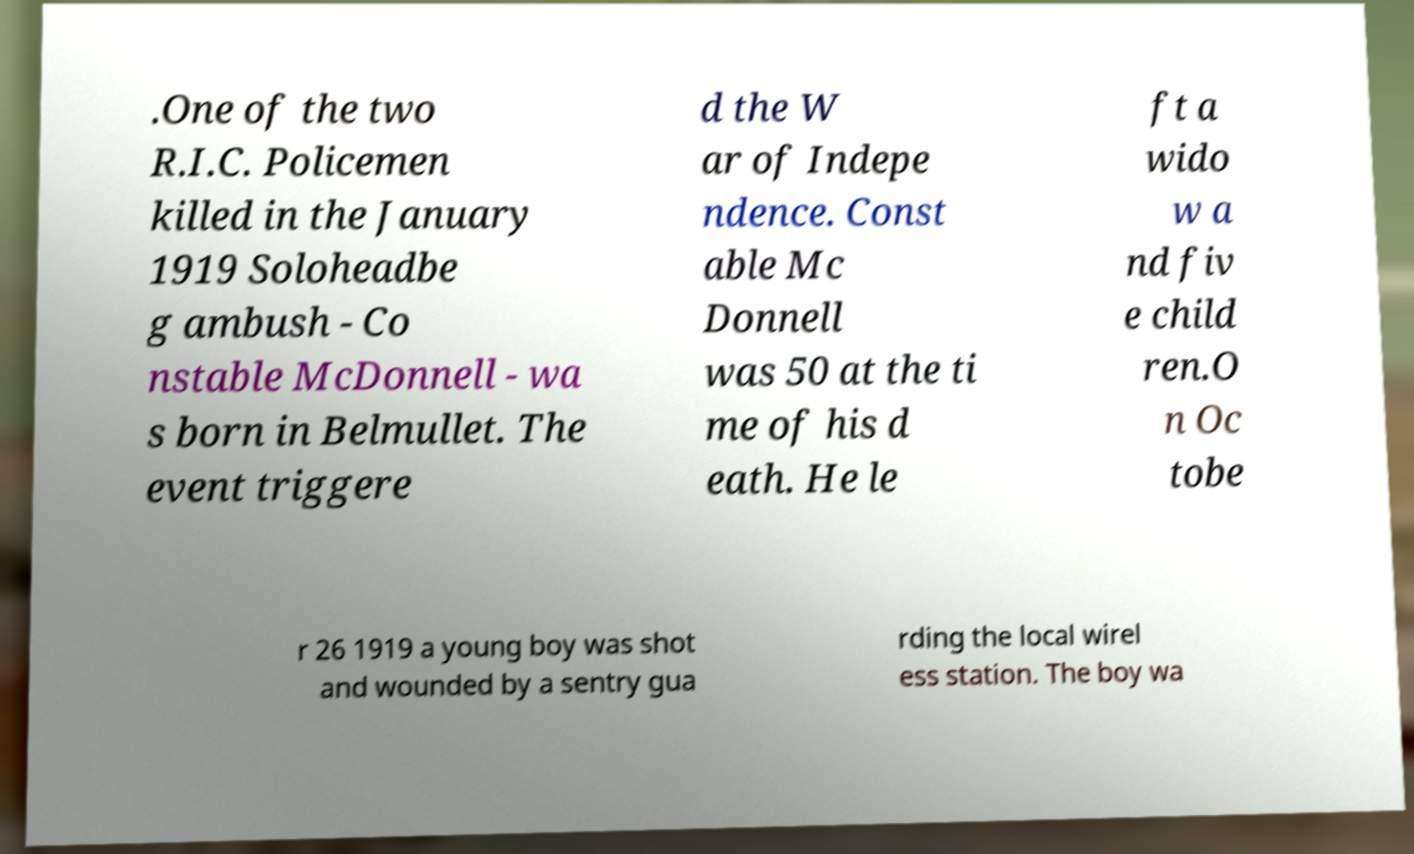Please read and relay the text visible in this image. What does it say? .One of the two R.I.C. Policemen killed in the January 1919 Soloheadbe g ambush - Co nstable McDonnell - wa s born in Belmullet. The event triggere d the W ar of Indepe ndence. Const able Mc Donnell was 50 at the ti me of his d eath. He le ft a wido w a nd fiv e child ren.O n Oc tobe r 26 1919 a young boy was shot and wounded by a sentry gua rding the local wirel ess station. The boy wa 